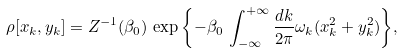Convert formula to latex. <formula><loc_0><loc_0><loc_500><loc_500>\rho [ x _ { k } , y _ { k } ] = Z ^ { - 1 } ( \beta _ { 0 } ) \, \exp { \left \{ - \beta _ { 0 } \, \int ^ { + \infty } _ { - \infty } \frac { d k } { 2 \pi } \omega _ { k } ( x _ { k } ^ { 2 } + y _ { k } ^ { 2 } ) \right \} } ,</formula> 